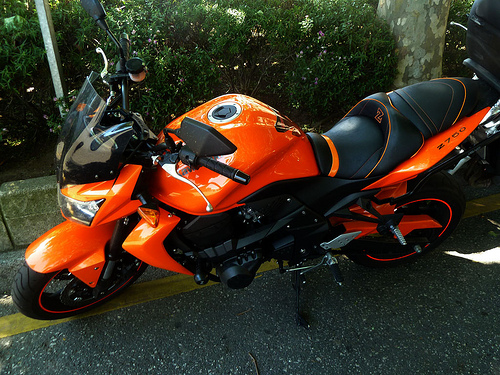<image>
Can you confirm if the bike is above the road? No. The bike is not positioned above the road. The vertical arrangement shows a different relationship. 